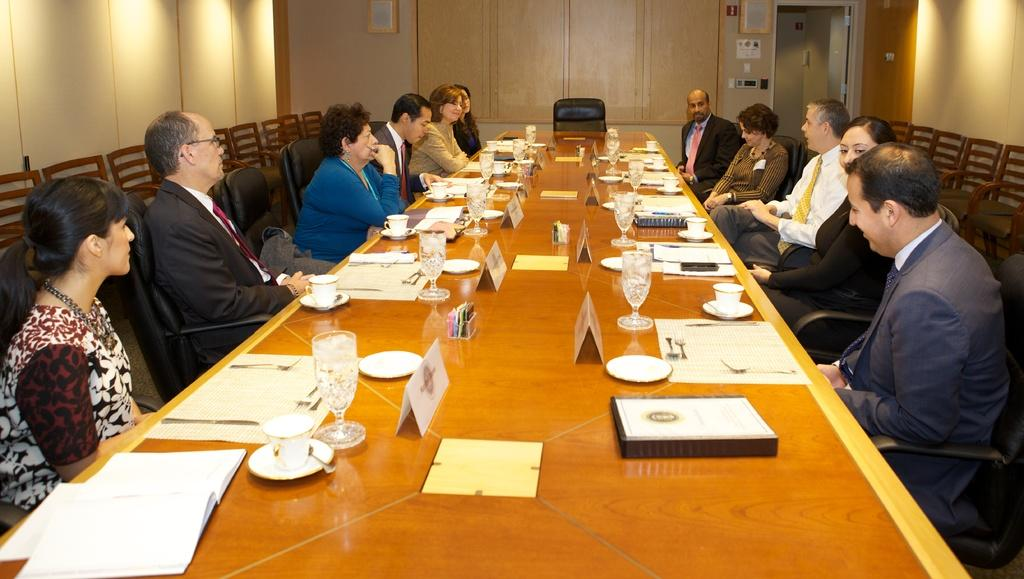What are the people in the image doing? The people in the image are sitting on chairs. What is present on the table in the image? There is a wine glass, a menu card, and a plate on the table. What might the people be using the menu card for? The people might be using the menu card to decide what to order. What type of plants can be seen growing on the afterthought in the image? There is no mention of plants or an afterthought in the image, so this question cannot be answered. 